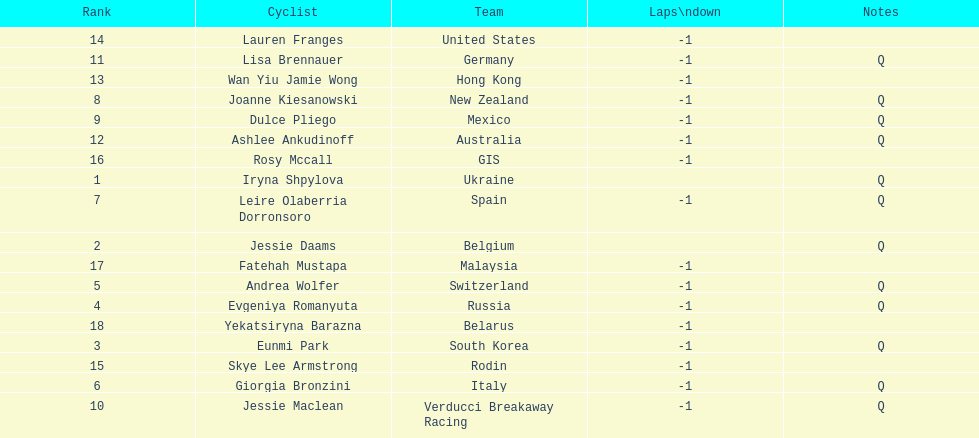How many cyclist do not have -1 laps down? 2. 